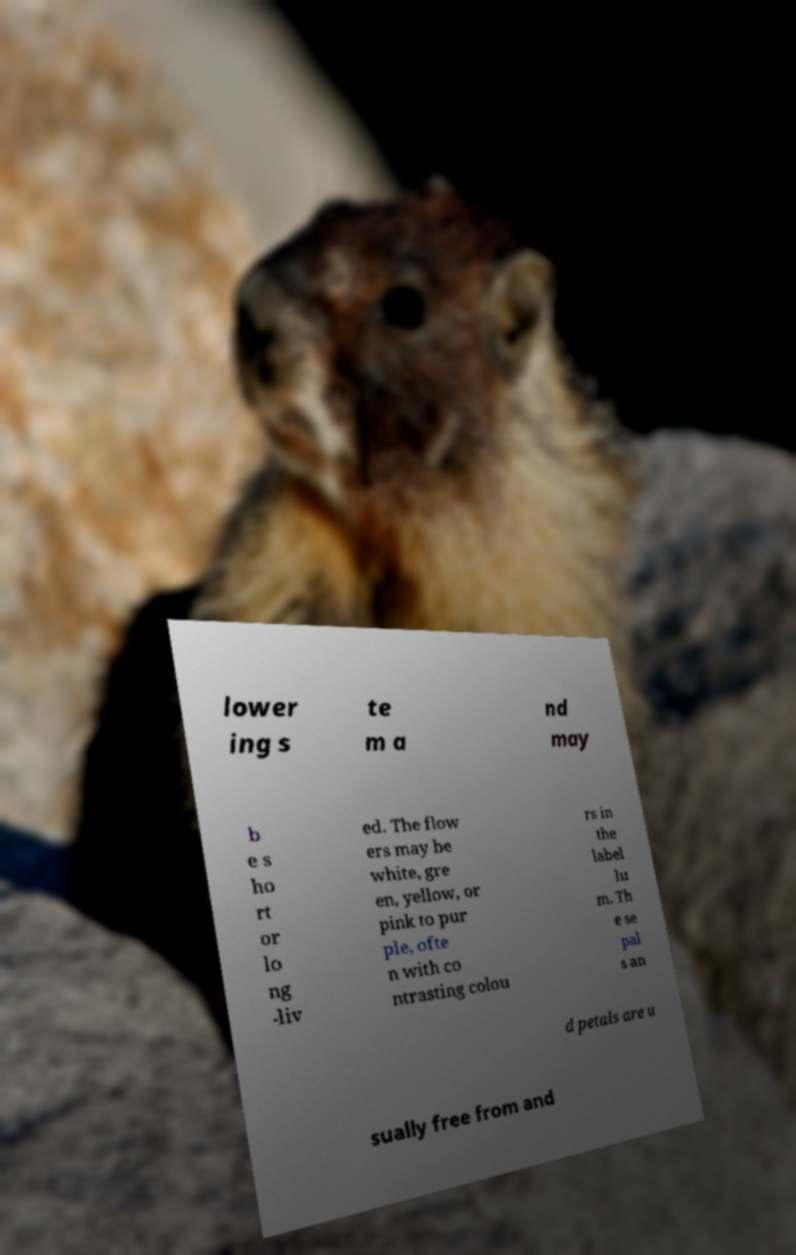For documentation purposes, I need the text within this image transcribed. Could you provide that? lower ing s te m a nd may b e s ho rt or lo ng -liv ed. The flow ers may be white, gre en, yellow, or pink to pur ple, ofte n with co ntrasting colou rs in the label lu m. Th e se pal s an d petals are u sually free from and 